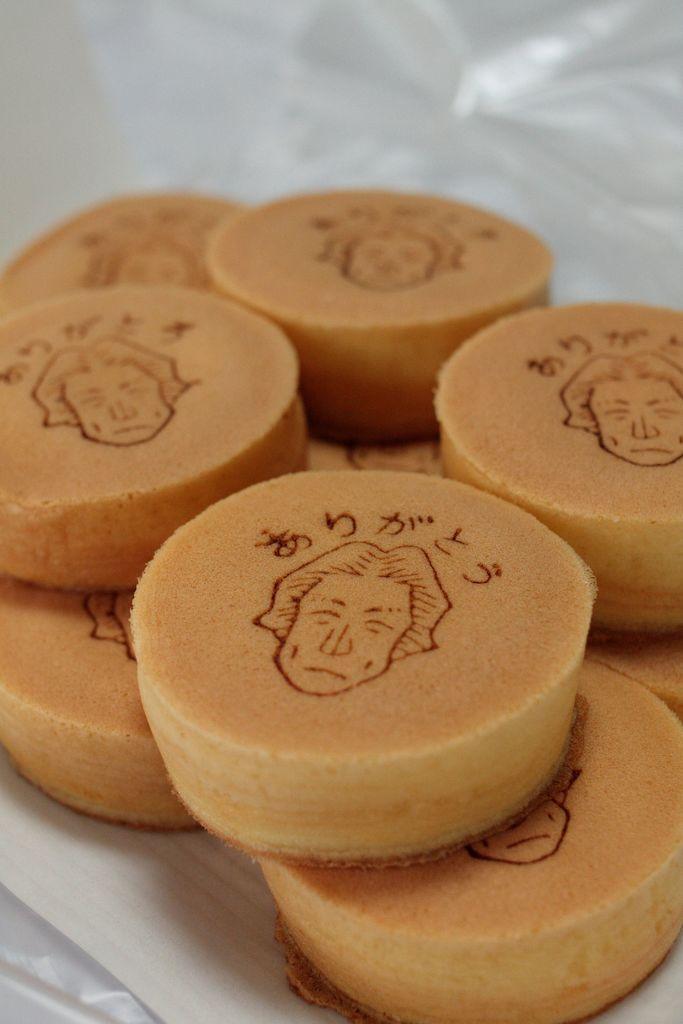Can you describe this image briefly? In this picture, we see the eatables which look like the cakes. In the background, it is white in color. It might be a sheet which is placed on the table. 